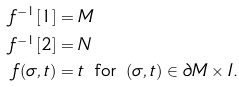<formula> <loc_0><loc_0><loc_500><loc_500>f ^ { - 1 } [ 1 ] & = M \\ f ^ { - 1 } [ 2 ] & = N \\ f ( \sigma , t ) & = t \, \text { for } \, ( \sigma , t ) \in \partial M \times I .</formula> 